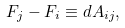Convert formula to latex. <formula><loc_0><loc_0><loc_500><loc_500>F _ { j } - F _ { i } \equiv d A _ { i j } ,</formula> 